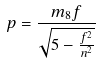<formula> <loc_0><loc_0><loc_500><loc_500>p = \frac { m _ { 8 } f } { \sqrt { 5 - \frac { f ^ { 2 } } { n ^ { 2 } } } }</formula> 